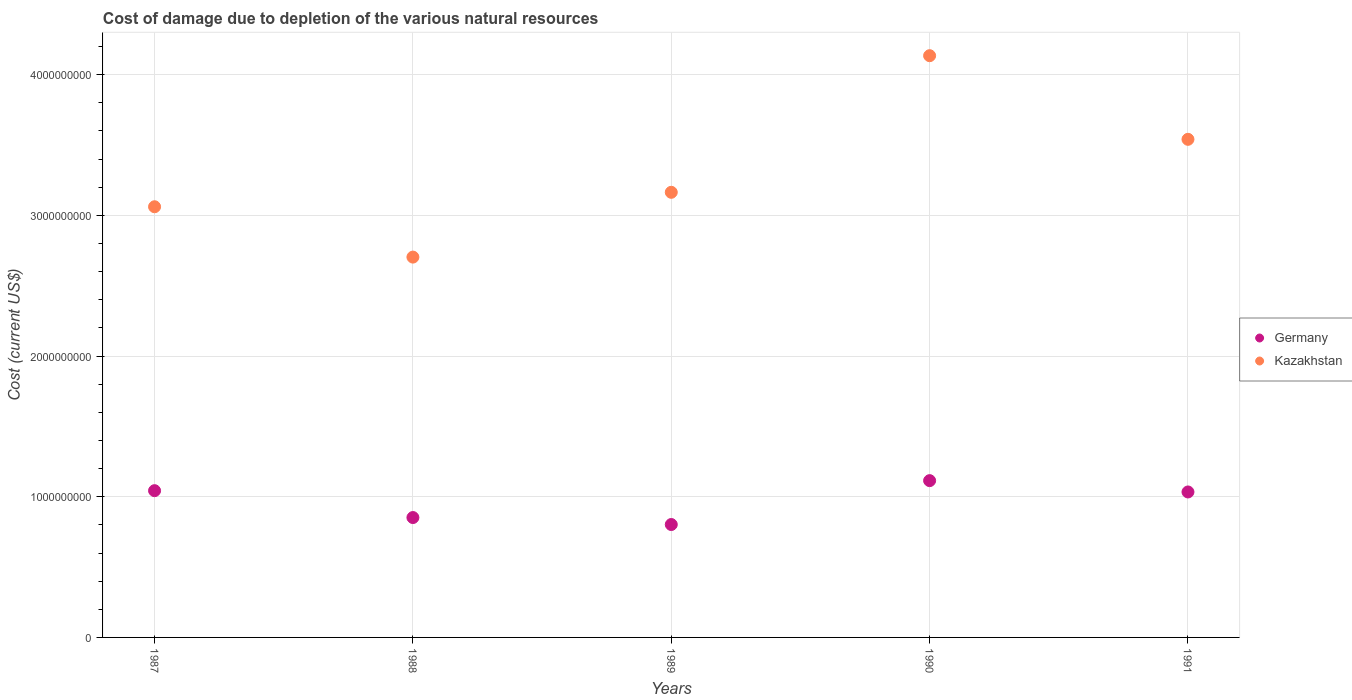How many different coloured dotlines are there?
Ensure brevity in your answer.  2. Is the number of dotlines equal to the number of legend labels?
Offer a terse response. Yes. What is the cost of damage caused due to the depletion of various natural resources in Germany in 1988?
Keep it short and to the point. 8.52e+08. Across all years, what is the maximum cost of damage caused due to the depletion of various natural resources in Germany?
Give a very brief answer. 1.11e+09. Across all years, what is the minimum cost of damage caused due to the depletion of various natural resources in Kazakhstan?
Your answer should be compact. 2.70e+09. What is the total cost of damage caused due to the depletion of various natural resources in Germany in the graph?
Offer a terse response. 4.85e+09. What is the difference between the cost of damage caused due to the depletion of various natural resources in Germany in 1990 and that in 1991?
Make the answer very short. 8.05e+07. What is the difference between the cost of damage caused due to the depletion of various natural resources in Kazakhstan in 1989 and the cost of damage caused due to the depletion of various natural resources in Germany in 1990?
Your answer should be compact. 2.05e+09. What is the average cost of damage caused due to the depletion of various natural resources in Kazakhstan per year?
Your answer should be compact. 3.32e+09. In the year 1989, what is the difference between the cost of damage caused due to the depletion of various natural resources in Kazakhstan and cost of damage caused due to the depletion of various natural resources in Germany?
Your answer should be compact. 2.36e+09. What is the ratio of the cost of damage caused due to the depletion of various natural resources in Kazakhstan in 1987 to that in 1989?
Your response must be concise. 0.97. Is the difference between the cost of damage caused due to the depletion of various natural resources in Kazakhstan in 1987 and 1988 greater than the difference between the cost of damage caused due to the depletion of various natural resources in Germany in 1987 and 1988?
Keep it short and to the point. Yes. What is the difference between the highest and the second highest cost of damage caused due to the depletion of various natural resources in Germany?
Make the answer very short. 7.13e+07. What is the difference between the highest and the lowest cost of damage caused due to the depletion of various natural resources in Kazakhstan?
Give a very brief answer. 1.43e+09. Does the cost of damage caused due to the depletion of various natural resources in Germany monotonically increase over the years?
Keep it short and to the point. No. Is the cost of damage caused due to the depletion of various natural resources in Kazakhstan strictly greater than the cost of damage caused due to the depletion of various natural resources in Germany over the years?
Make the answer very short. Yes. Is the cost of damage caused due to the depletion of various natural resources in Kazakhstan strictly less than the cost of damage caused due to the depletion of various natural resources in Germany over the years?
Keep it short and to the point. No. How many years are there in the graph?
Your answer should be very brief. 5. Where does the legend appear in the graph?
Your answer should be compact. Center right. How many legend labels are there?
Provide a succinct answer. 2. What is the title of the graph?
Give a very brief answer. Cost of damage due to depletion of the various natural resources. What is the label or title of the X-axis?
Offer a terse response. Years. What is the label or title of the Y-axis?
Offer a terse response. Cost (current US$). What is the Cost (current US$) in Germany in 1987?
Provide a succinct answer. 1.04e+09. What is the Cost (current US$) of Kazakhstan in 1987?
Your answer should be compact. 3.06e+09. What is the Cost (current US$) in Germany in 1988?
Your answer should be very brief. 8.52e+08. What is the Cost (current US$) of Kazakhstan in 1988?
Provide a succinct answer. 2.70e+09. What is the Cost (current US$) of Germany in 1989?
Your response must be concise. 8.02e+08. What is the Cost (current US$) of Kazakhstan in 1989?
Provide a short and direct response. 3.16e+09. What is the Cost (current US$) of Germany in 1990?
Offer a very short reply. 1.11e+09. What is the Cost (current US$) in Kazakhstan in 1990?
Your answer should be compact. 4.13e+09. What is the Cost (current US$) in Germany in 1991?
Your answer should be compact. 1.03e+09. What is the Cost (current US$) in Kazakhstan in 1991?
Your response must be concise. 3.54e+09. Across all years, what is the maximum Cost (current US$) of Germany?
Keep it short and to the point. 1.11e+09. Across all years, what is the maximum Cost (current US$) of Kazakhstan?
Provide a short and direct response. 4.13e+09. Across all years, what is the minimum Cost (current US$) in Germany?
Provide a short and direct response. 8.02e+08. Across all years, what is the minimum Cost (current US$) in Kazakhstan?
Offer a very short reply. 2.70e+09. What is the total Cost (current US$) in Germany in the graph?
Give a very brief answer. 4.85e+09. What is the total Cost (current US$) of Kazakhstan in the graph?
Provide a short and direct response. 1.66e+1. What is the difference between the Cost (current US$) in Germany in 1987 and that in 1988?
Provide a short and direct response. 1.91e+08. What is the difference between the Cost (current US$) in Kazakhstan in 1987 and that in 1988?
Your answer should be very brief. 3.58e+08. What is the difference between the Cost (current US$) in Germany in 1987 and that in 1989?
Offer a very short reply. 2.41e+08. What is the difference between the Cost (current US$) in Kazakhstan in 1987 and that in 1989?
Keep it short and to the point. -1.03e+08. What is the difference between the Cost (current US$) of Germany in 1987 and that in 1990?
Your answer should be very brief. -7.13e+07. What is the difference between the Cost (current US$) in Kazakhstan in 1987 and that in 1990?
Ensure brevity in your answer.  -1.07e+09. What is the difference between the Cost (current US$) in Germany in 1987 and that in 1991?
Your answer should be very brief. 9.16e+06. What is the difference between the Cost (current US$) of Kazakhstan in 1987 and that in 1991?
Your answer should be compact. -4.79e+08. What is the difference between the Cost (current US$) in Germany in 1988 and that in 1989?
Your response must be concise. 4.96e+07. What is the difference between the Cost (current US$) in Kazakhstan in 1988 and that in 1989?
Provide a succinct answer. -4.61e+08. What is the difference between the Cost (current US$) in Germany in 1988 and that in 1990?
Your answer should be very brief. -2.62e+08. What is the difference between the Cost (current US$) of Kazakhstan in 1988 and that in 1990?
Make the answer very short. -1.43e+09. What is the difference between the Cost (current US$) in Germany in 1988 and that in 1991?
Keep it short and to the point. -1.82e+08. What is the difference between the Cost (current US$) in Kazakhstan in 1988 and that in 1991?
Your response must be concise. -8.37e+08. What is the difference between the Cost (current US$) of Germany in 1989 and that in 1990?
Give a very brief answer. -3.12e+08. What is the difference between the Cost (current US$) of Kazakhstan in 1989 and that in 1990?
Your answer should be very brief. -9.71e+08. What is the difference between the Cost (current US$) of Germany in 1989 and that in 1991?
Give a very brief answer. -2.31e+08. What is the difference between the Cost (current US$) in Kazakhstan in 1989 and that in 1991?
Your response must be concise. -3.77e+08. What is the difference between the Cost (current US$) of Germany in 1990 and that in 1991?
Give a very brief answer. 8.05e+07. What is the difference between the Cost (current US$) in Kazakhstan in 1990 and that in 1991?
Ensure brevity in your answer.  5.94e+08. What is the difference between the Cost (current US$) of Germany in 1987 and the Cost (current US$) of Kazakhstan in 1988?
Keep it short and to the point. -1.66e+09. What is the difference between the Cost (current US$) of Germany in 1987 and the Cost (current US$) of Kazakhstan in 1989?
Offer a terse response. -2.12e+09. What is the difference between the Cost (current US$) in Germany in 1987 and the Cost (current US$) in Kazakhstan in 1990?
Your answer should be compact. -3.09e+09. What is the difference between the Cost (current US$) of Germany in 1987 and the Cost (current US$) of Kazakhstan in 1991?
Your answer should be compact. -2.50e+09. What is the difference between the Cost (current US$) in Germany in 1988 and the Cost (current US$) in Kazakhstan in 1989?
Your answer should be very brief. -2.31e+09. What is the difference between the Cost (current US$) of Germany in 1988 and the Cost (current US$) of Kazakhstan in 1990?
Make the answer very short. -3.28e+09. What is the difference between the Cost (current US$) in Germany in 1988 and the Cost (current US$) in Kazakhstan in 1991?
Offer a very short reply. -2.69e+09. What is the difference between the Cost (current US$) in Germany in 1989 and the Cost (current US$) in Kazakhstan in 1990?
Ensure brevity in your answer.  -3.33e+09. What is the difference between the Cost (current US$) in Germany in 1989 and the Cost (current US$) in Kazakhstan in 1991?
Provide a short and direct response. -2.74e+09. What is the difference between the Cost (current US$) of Germany in 1990 and the Cost (current US$) of Kazakhstan in 1991?
Offer a very short reply. -2.43e+09. What is the average Cost (current US$) of Germany per year?
Make the answer very short. 9.69e+08. What is the average Cost (current US$) in Kazakhstan per year?
Provide a short and direct response. 3.32e+09. In the year 1987, what is the difference between the Cost (current US$) in Germany and Cost (current US$) in Kazakhstan?
Make the answer very short. -2.02e+09. In the year 1988, what is the difference between the Cost (current US$) of Germany and Cost (current US$) of Kazakhstan?
Keep it short and to the point. -1.85e+09. In the year 1989, what is the difference between the Cost (current US$) in Germany and Cost (current US$) in Kazakhstan?
Keep it short and to the point. -2.36e+09. In the year 1990, what is the difference between the Cost (current US$) of Germany and Cost (current US$) of Kazakhstan?
Ensure brevity in your answer.  -3.02e+09. In the year 1991, what is the difference between the Cost (current US$) in Germany and Cost (current US$) in Kazakhstan?
Provide a succinct answer. -2.51e+09. What is the ratio of the Cost (current US$) of Germany in 1987 to that in 1988?
Your answer should be compact. 1.22. What is the ratio of the Cost (current US$) in Kazakhstan in 1987 to that in 1988?
Provide a succinct answer. 1.13. What is the ratio of the Cost (current US$) in Germany in 1987 to that in 1989?
Keep it short and to the point. 1.3. What is the ratio of the Cost (current US$) in Kazakhstan in 1987 to that in 1989?
Give a very brief answer. 0.97. What is the ratio of the Cost (current US$) of Germany in 1987 to that in 1990?
Offer a terse response. 0.94. What is the ratio of the Cost (current US$) of Kazakhstan in 1987 to that in 1990?
Ensure brevity in your answer.  0.74. What is the ratio of the Cost (current US$) of Germany in 1987 to that in 1991?
Offer a very short reply. 1.01. What is the ratio of the Cost (current US$) in Kazakhstan in 1987 to that in 1991?
Your response must be concise. 0.86. What is the ratio of the Cost (current US$) in Germany in 1988 to that in 1989?
Your answer should be very brief. 1.06. What is the ratio of the Cost (current US$) of Kazakhstan in 1988 to that in 1989?
Your response must be concise. 0.85. What is the ratio of the Cost (current US$) in Germany in 1988 to that in 1990?
Offer a very short reply. 0.76. What is the ratio of the Cost (current US$) of Kazakhstan in 1988 to that in 1990?
Your answer should be compact. 0.65. What is the ratio of the Cost (current US$) in Germany in 1988 to that in 1991?
Your answer should be compact. 0.82. What is the ratio of the Cost (current US$) of Kazakhstan in 1988 to that in 1991?
Ensure brevity in your answer.  0.76. What is the ratio of the Cost (current US$) in Germany in 1989 to that in 1990?
Ensure brevity in your answer.  0.72. What is the ratio of the Cost (current US$) of Kazakhstan in 1989 to that in 1990?
Provide a succinct answer. 0.77. What is the ratio of the Cost (current US$) in Germany in 1989 to that in 1991?
Give a very brief answer. 0.78. What is the ratio of the Cost (current US$) of Kazakhstan in 1989 to that in 1991?
Make the answer very short. 0.89. What is the ratio of the Cost (current US$) of Germany in 1990 to that in 1991?
Your answer should be compact. 1.08. What is the ratio of the Cost (current US$) of Kazakhstan in 1990 to that in 1991?
Your answer should be compact. 1.17. What is the difference between the highest and the second highest Cost (current US$) of Germany?
Offer a terse response. 7.13e+07. What is the difference between the highest and the second highest Cost (current US$) in Kazakhstan?
Provide a short and direct response. 5.94e+08. What is the difference between the highest and the lowest Cost (current US$) in Germany?
Provide a short and direct response. 3.12e+08. What is the difference between the highest and the lowest Cost (current US$) in Kazakhstan?
Ensure brevity in your answer.  1.43e+09. 